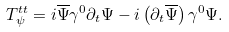Convert formula to latex. <formula><loc_0><loc_0><loc_500><loc_500>T ^ { t t } _ { \psi } = i \overline { \Psi } \gamma ^ { 0 } \partial _ { t } \Psi - i \left ( \partial _ { t } \overline { \Psi } \right ) \gamma ^ { 0 } \Psi .</formula> 